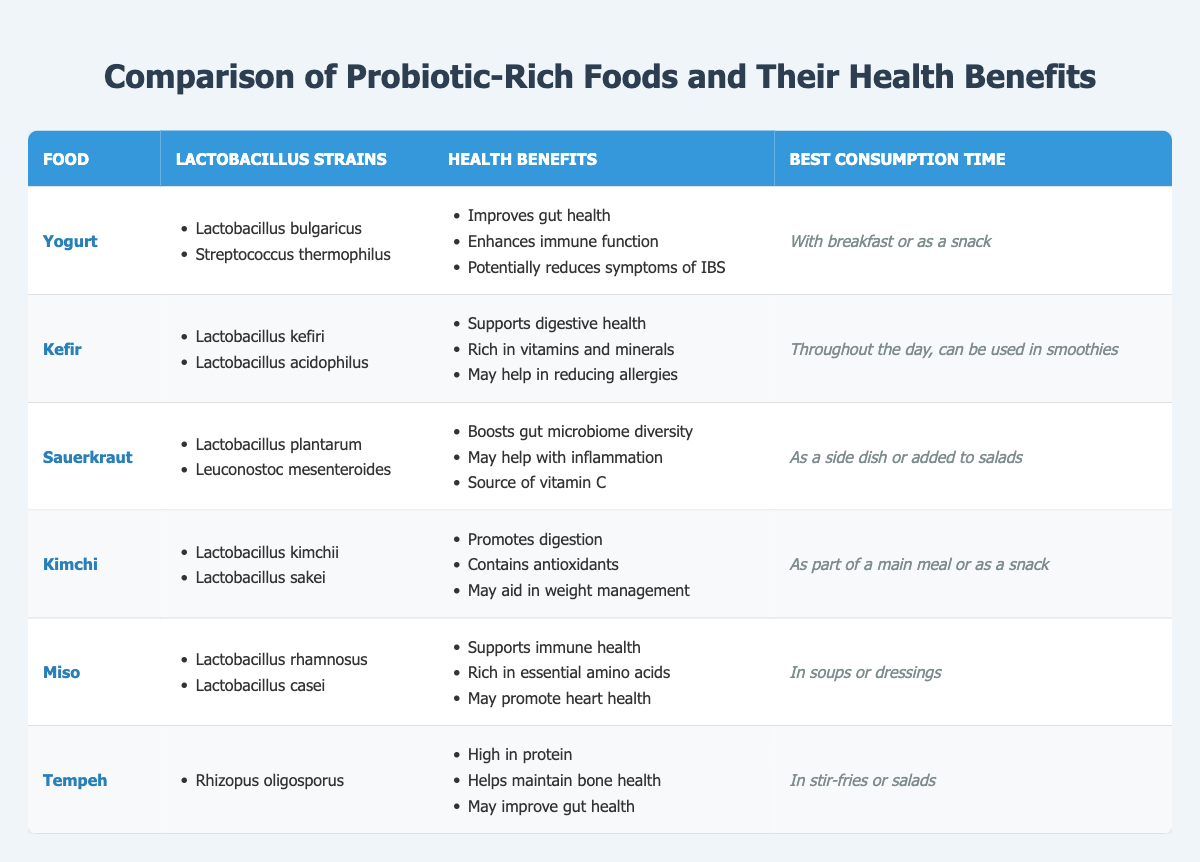What are the lactobacillus strains found in yogurt? The table lists yogurt along with its lactobacillus strains, specifically stating "Lactobacillus bulgaricus" and "Streptococcus thermophilus."
Answer: Lactobacillus bulgaricus, Streptococcus thermophilus Which probiotic food is rich in essential amino acids? The table indicates that miso offers benefits including being "rich in essential amino acids," making it the probiotic food associated with this benefit.
Answer: Miso True or False: Kimchi helps in reducing allergies. The health benefits listed for kimchi do not include any reference to allergies, so this statement is false based on the information.
Answer: False What is the best consumption time for sauerkraut? The table specifies that sauerkraut is best consumed "as a side dish or added to salads," directly answering the question.
Answer: As a side dish or added to salads How many probiotic foods listed may aid in weight management? Referring to the table, only kimchi explicitly mentions an aid in weight management, indicating that there is one probiotic food associated with this benefit.
Answer: 1 Which food contains the lactobacillus strain Lactobacillus plantarum? The table shows that sauerkraut is the food that includes the lactobacillus strain Lactobacillus plantarum in its list of strains.
Answer: Sauerkraut Does kefir support immune health? The benefits listed for kefir do not mention immune health; thus, it is incorrect to say that kefir supports immune health based on the provided data.
Answer: No Compare the health benefits of yogurt and kefir. Which has more benefits listed? Counting the health benefits, yogurt lists 3 benefits and kefir also lists 3 benefits, so they have the same number of listed health benefits.
Answer: They have the same number 